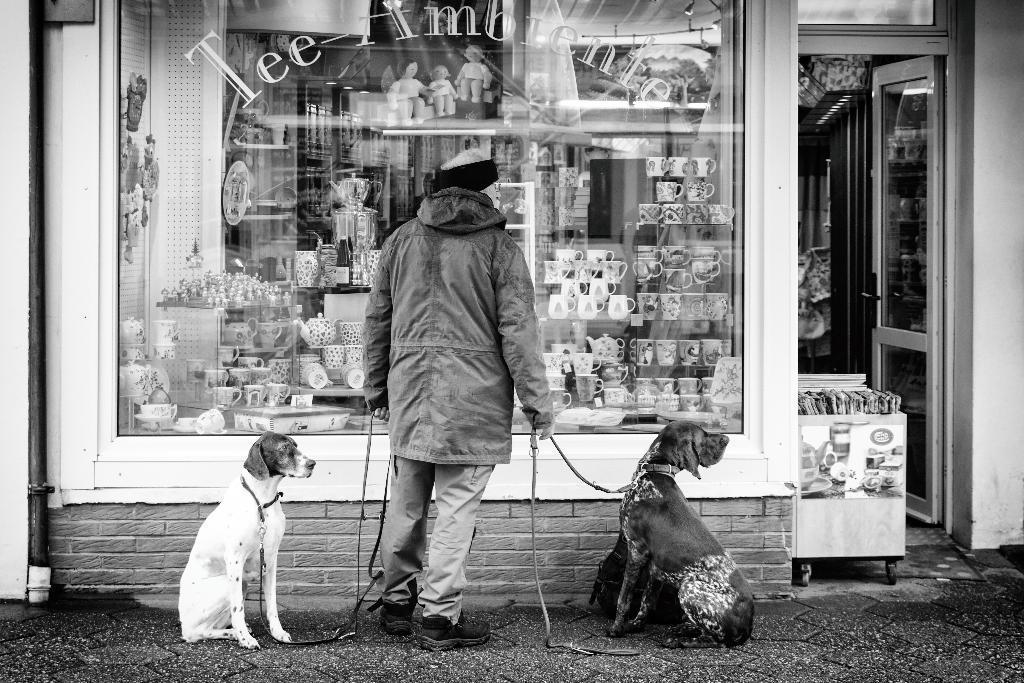In one or two sentences, can you explain what this image depicts? This is a black and white image. There is a man standing with the jacket and holding the belts of the two dogs which are sitting on the floor. In front of the him there is a store with glass door. Behind the glass door there are cups arranged in a row. On the right side of the image there is a door and also there is a stroller with few items on it. On the left side of the image there is a pipe to the wall. 